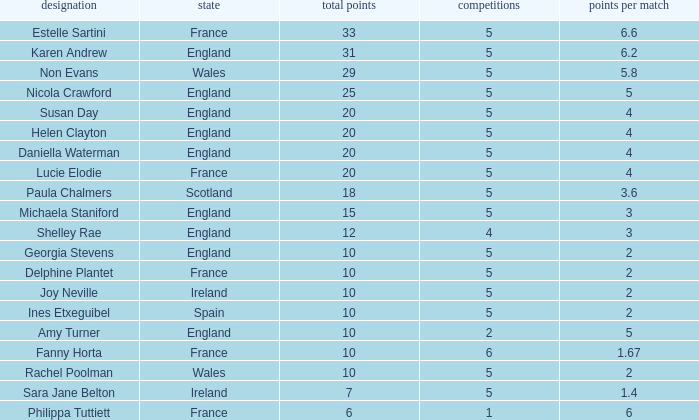Can you tell me the lowest Pts/game that has the Games larger than 6? None. 